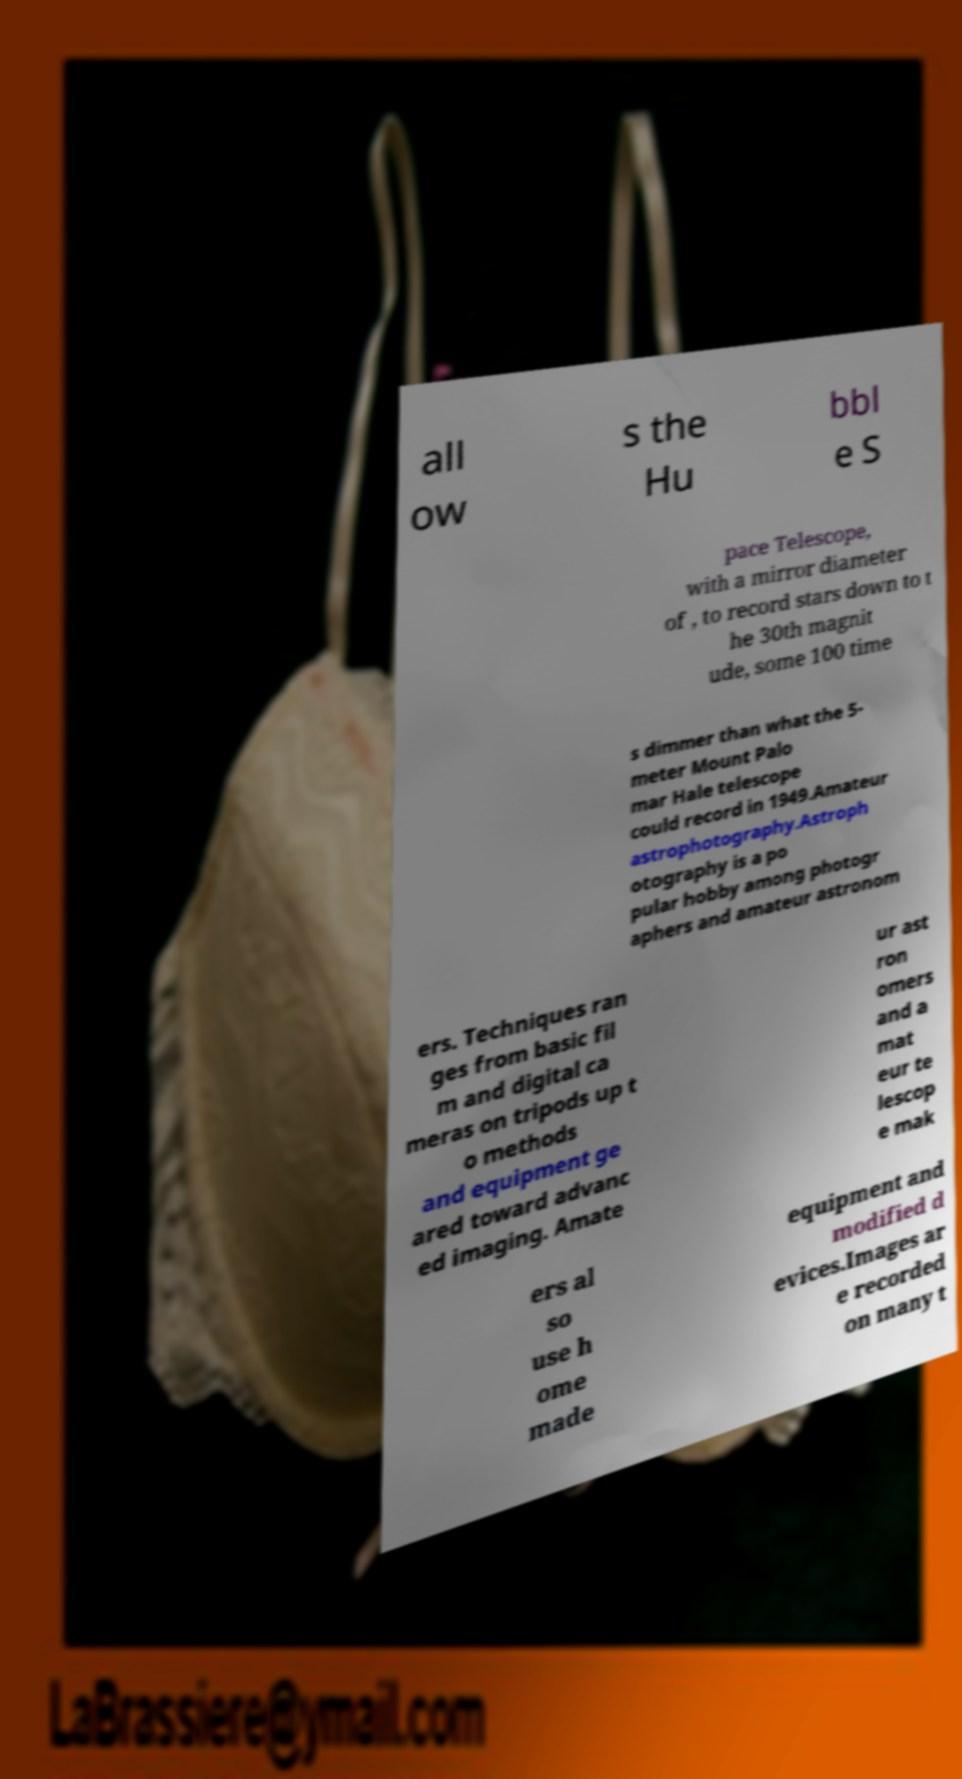For documentation purposes, I need the text within this image transcribed. Could you provide that? all ow s the Hu bbl e S pace Telescope, with a mirror diameter of , to record stars down to t he 30th magnit ude, some 100 time s dimmer than what the 5- meter Mount Palo mar Hale telescope could record in 1949.Amateur astrophotography.Astroph otography is a po pular hobby among photogr aphers and amateur astronom ers. Techniques ran ges from basic fil m and digital ca meras on tripods up t o methods and equipment ge ared toward advanc ed imaging. Amate ur ast ron omers and a mat eur te lescop e mak ers al so use h ome made equipment and modified d evices.Images ar e recorded on many t 